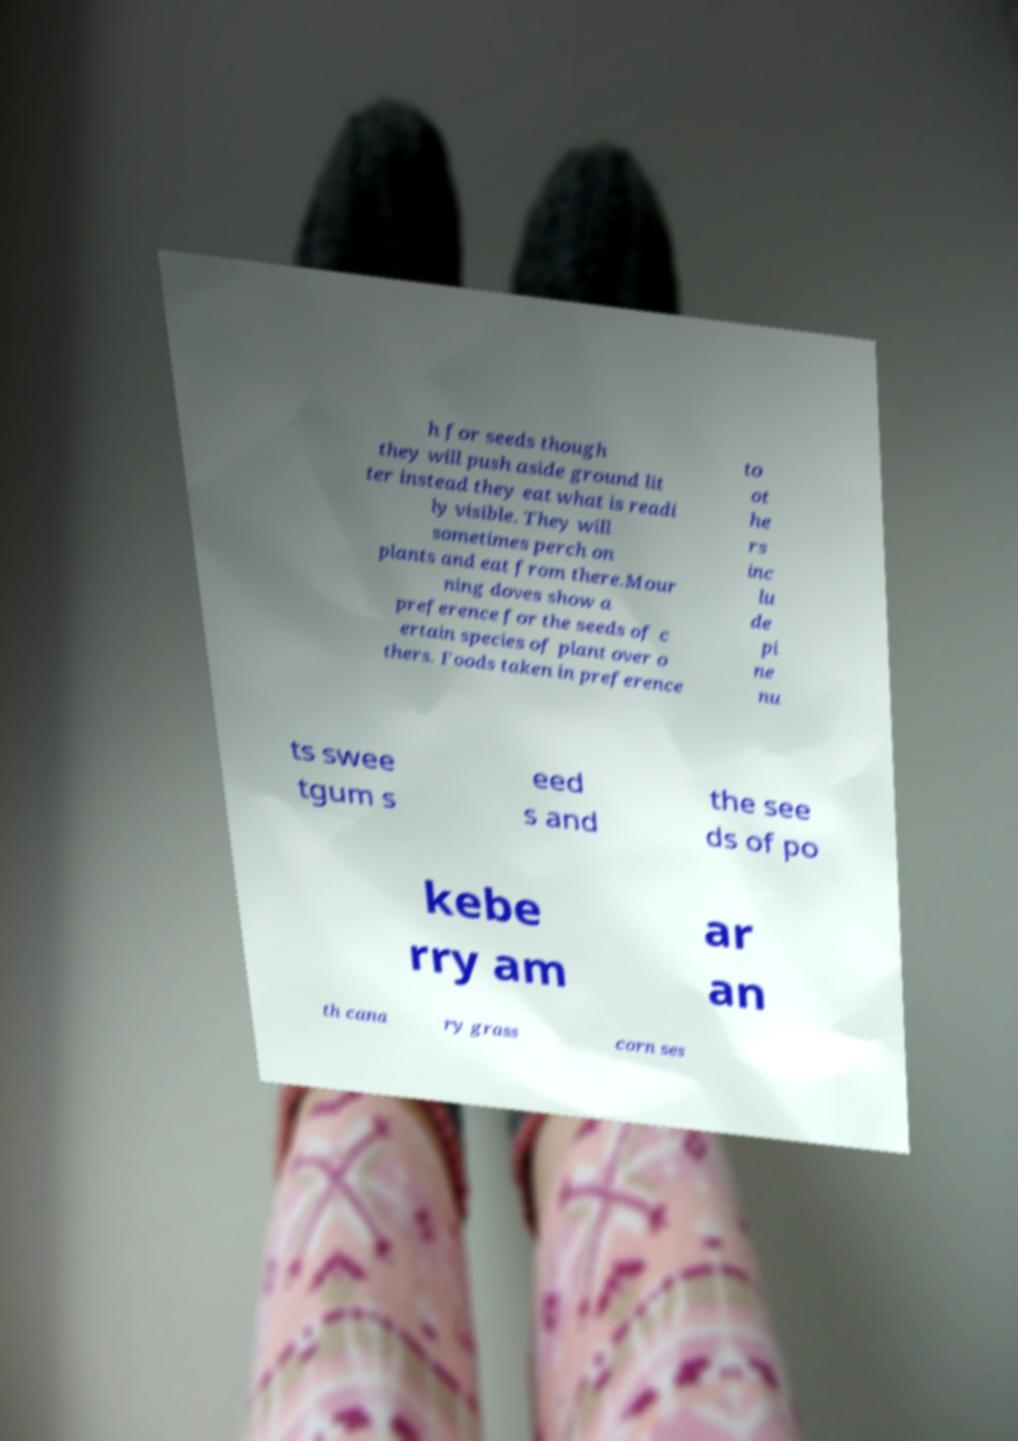What messages or text are displayed in this image? I need them in a readable, typed format. h for seeds though they will push aside ground lit ter instead they eat what is readi ly visible. They will sometimes perch on plants and eat from there.Mour ning doves show a preference for the seeds of c ertain species of plant over o thers. Foods taken in preference to ot he rs inc lu de pi ne nu ts swee tgum s eed s and the see ds of po kebe rry am ar an th cana ry grass corn ses 